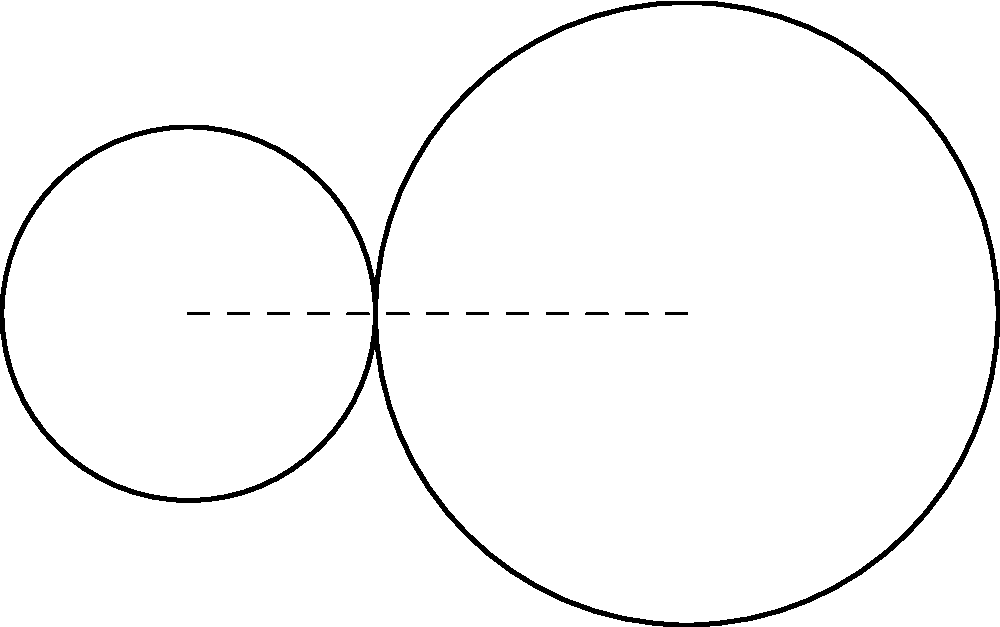In the gear system shown above, Gear 1 has 20 teeth and rotates at 120 rpm clockwise. Gear 2 has 50 teeth. Calculate the angular velocity ($\omega_2$) of Gear 2 in rpm. Assume no slippage between the gears. To solve this problem, we'll use the concept of gear ratio and the relationship between the number of teeth and angular velocities of meshing gears.

Step 1: Determine the gear ratio.
The gear ratio is defined as the ratio of the number of teeth on the driven gear to the number of teeth on the driving gear.
Gear ratio = $\frac{N_2}{N_1} = \frac{50}{20} = 2.5$

Step 2: Use the gear ratio to relate the angular velocities.
For meshing gears, the following relationship holds:
$\frac{\omega_1}{\omega_2} = \frac{N_2}{N_1}$

Step 3: Substitute the known values and solve for $\omega_2$.
$\frac{120\text{ rpm}}{\omega_2} = \frac{50}{20}$

$\omega_2 = \frac{120\text{ rpm} \times 20}{50} = 48\text{ rpm}$

Step 4: Determine the direction of rotation.
Since Gear 1 rotates clockwise, Gear 2 will rotate counterclockwise.

Therefore, Gear 2 rotates at 48 rpm counterclockwise.
Answer: 48 rpm counterclockwise 